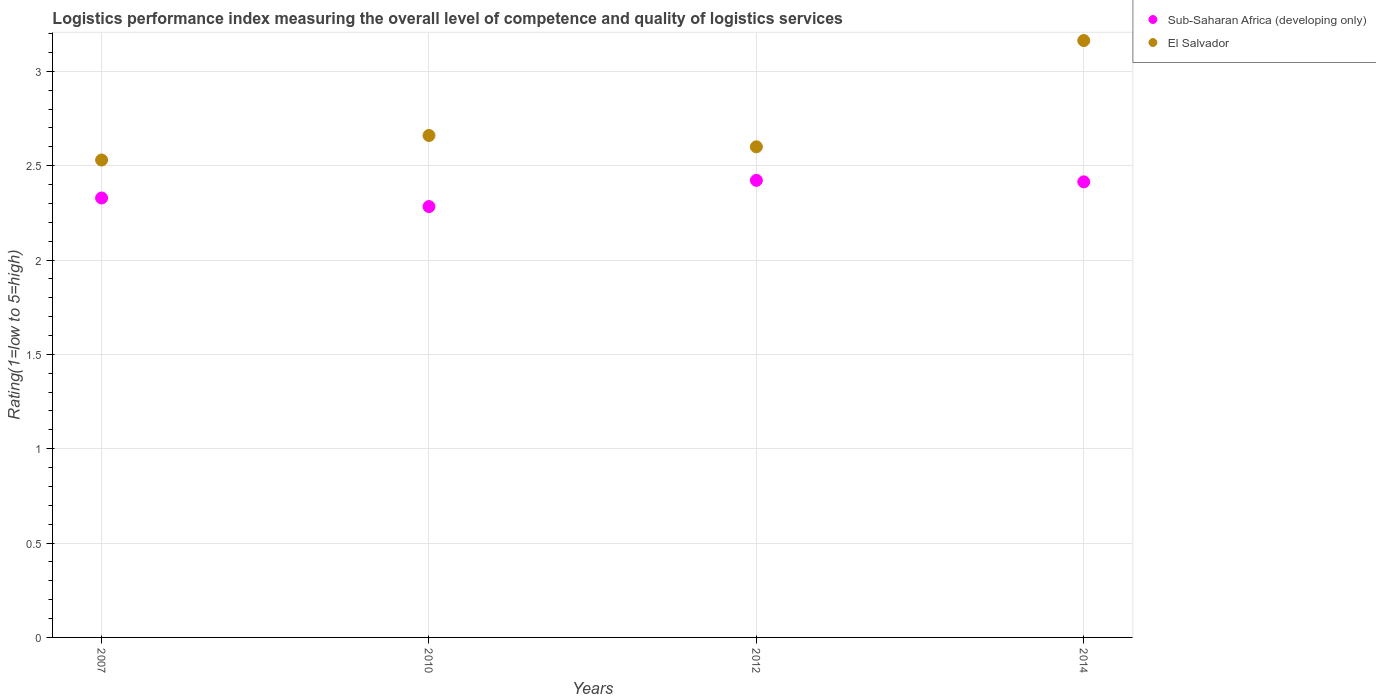How many different coloured dotlines are there?
Give a very brief answer. 2. Is the number of dotlines equal to the number of legend labels?
Your response must be concise. Yes. What is the Logistic performance index in Sub-Saharan Africa (developing only) in 2010?
Ensure brevity in your answer.  2.28. Across all years, what is the maximum Logistic performance index in Sub-Saharan Africa (developing only)?
Your answer should be compact. 2.42. Across all years, what is the minimum Logistic performance index in Sub-Saharan Africa (developing only)?
Your answer should be compact. 2.28. In which year was the Logistic performance index in El Salvador minimum?
Provide a short and direct response. 2007. What is the total Logistic performance index in El Salvador in the graph?
Give a very brief answer. 10.95. What is the difference between the Logistic performance index in Sub-Saharan Africa (developing only) in 2007 and that in 2012?
Your answer should be very brief. -0.09. What is the difference between the Logistic performance index in Sub-Saharan Africa (developing only) in 2014 and the Logistic performance index in El Salvador in 2012?
Provide a succinct answer. -0.19. What is the average Logistic performance index in Sub-Saharan Africa (developing only) per year?
Your answer should be very brief. 2.36. In the year 2014, what is the difference between the Logistic performance index in Sub-Saharan Africa (developing only) and Logistic performance index in El Salvador?
Provide a short and direct response. -0.75. In how many years, is the Logistic performance index in El Salvador greater than 2.6?
Offer a very short reply. 2. What is the ratio of the Logistic performance index in Sub-Saharan Africa (developing only) in 2012 to that in 2014?
Your answer should be very brief. 1. What is the difference between the highest and the second highest Logistic performance index in Sub-Saharan Africa (developing only)?
Provide a succinct answer. 0.01. What is the difference between the highest and the lowest Logistic performance index in Sub-Saharan Africa (developing only)?
Offer a very short reply. 0.14. In how many years, is the Logistic performance index in El Salvador greater than the average Logistic performance index in El Salvador taken over all years?
Give a very brief answer. 1. Is the sum of the Logistic performance index in El Salvador in 2010 and 2014 greater than the maximum Logistic performance index in Sub-Saharan Africa (developing only) across all years?
Your answer should be very brief. Yes. How many dotlines are there?
Your answer should be very brief. 2. What is the difference between two consecutive major ticks on the Y-axis?
Your answer should be very brief. 0.5. Are the values on the major ticks of Y-axis written in scientific E-notation?
Make the answer very short. No. Does the graph contain any zero values?
Offer a very short reply. No. What is the title of the graph?
Ensure brevity in your answer.  Logistics performance index measuring the overall level of competence and quality of logistics services. Does "Low income" appear as one of the legend labels in the graph?
Your answer should be compact. No. What is the label or title of the X-axis?
Offer a very short reply. Years. What is the label or title of the Y-axis?
Your answer should be very brief. Rating(1=low to 5=high). What is the Rating(1=low to 5=high) in Sub-Saharan Africa (developing only) in 2007?
Your response must be concise. 2.33. What is the Rating(1=low to 5=high) in El Salvador in 2007?
Your answer should be compact. 2.53. What is the Rating(1=low to 5=high) of Sub-Saharan Africa (developing only) in 2010?
Give a very brief answer. 2.28. What is the Rating(1=low to 5=high) in El Salvador in 2010?
Keep it short and to the point. 2.66. What is the Rating(1=low to 5=high) in Sub-Saharan Africa (developing only) in 2012?
Ensure brevity in your answer.  2.42. What is the Rating(1=low to 5=high) of El Salvador in 2012?
Offer a very short reply. 2.6. What is the Rating(1=low to 5=high) of Sub-Saharan Africa (developing only) in 2014?
Your answer should be very brief. 2.41. What is the Rating(1=low to 5=high) of El Salvador in 2014?
Make the answer very short. 3.16. Across all years, what is the maximum Rating(1=low to 5=high) in Sub-Saharan Africa (developing only)?
Your response must be concise. 2.42. Across all years, what is the maximum Rating(1=low to 5=high) in El Salvador?
Your response must be concise. 3.16. Across all years, what is the minimum Rating(1=low to 5=high) in Sub-Saharan Africa (developing only)?
Offer a terse response. 2.28. Across all years, what is the minimum Rating(1=low to 5=high) of El Salvador?
Provide a short and direct response. 2.53. What is the total Rating(1=low to 5=high) in Sub-Saharan Africa (developing only) in the graph?
Give a very brief answer. 9.45. What is the total Rating(1=low to 5=high) of El Salvador in the graph?
Give a very brief answer. 10.95. What is the difference between the Rating(1=low to 5=high) of Sub-Saharan Africa (developing only) in 2007 and that in 2010?
Give a very brief answer. 0.05. What is the difference between the Rating(1=low to 5=high) in El Salvador in 2007 and that in 2010?
Offer a terse response. -0.13. What is the difference between the Rating(1=low to 5=high) in Sub-Saharan Africa (developing only) in 2007 and that in 2012?
Offer a terse response. -0.09. What is the difference between the Rating(1=low to 5=high) in El Salvador in 2007 and that in 2012?
Give a very brief answer. -0.07. What is the difference between the Rating(1=low to 5=high) of Sub-Saharan Africa (developing only) in 2007 and that in 2014?
Offer a terse response. -0.09. What is the difference between the Rating(1=low to 5=high) of El Salvador in 2007 and that in 2014?
Your answer should be compact. -0.63. What is the difference between the Rating(1=low to 5=high) of Sub-Saharan Africa (developing only) in 2010 and that in 2012?
Your answer should be compact. -0.14. What is the difference between the Rating(1=low to 5=high) in El Salvador in 2010 and that in 2012?
Make the answer very short. 0.06. What is the difference between the Rating(1=low to 5=high) of Sub-Saharan Africa (developing only) in 2010 and that in 2014?
Your answer should be very brief. -0.13. What is the difference between the Rating(1=low to 5=high) of El Salvador in 2010 and that in 2014?
Your answer should be compact. -0.5. What is the difference between the Rating(1=low to 5=high) in Sub-Saharan Africa (developing only) in 2012 and that in 2014?
Keep it short and to the point. 0.01. What is the difference between the Rating(1=low to 5=high) of El Salvador in 2012 and that in 2014?
Ensure brevity in your answer.  -0.56. What is the difference between the Rating(1=low to 5=high) in Sub-Saharan Africa (developing only) in 2007 and the Rating(1=low to 5=high) in El Salvador in 2010?
Give a very brief answer. -0.33. What is the difference between the Rating(1=low to 5=high) in Sub-Saharan Africa (developing only) in 2007 and the Rating(1=low to 5=high) in El Salvador in 2012?
Make the answer very short. -0.27. What is the difference between the Rating(1=low to 5=high) in Sub-Saharan Africa (developing only) in 2007 and the Rating(1=low to 5=high) in El Salvador in 2014?
Ensure brevity in your answer.  -0.83. What is the difference between the Rating(1=low to 5=high) of Sub-Saharan Africa (developing only) in 2010 and the Rating(1=low to 5=high) of El Salvador in 2012?
Ensure brevity in your answer.  -0.32. What is the difference between the Rating(1=low to 5=high) of Sub-Saharan Africa (developing only) in 2010 and the Rating(1=low to 5=high) of El Salvador in 2014?
Ensure brevity in your answer.  -0.88. What is the difference between the Rating(1=low to 5=high) in Sub-Saharan Africa (developing only) in 2012 and the Rating(1=low to 5=high) in El Salvador in 2014?
Make the answer very short. -0.74. What is the average Rating(1=low to 5=high) in Sub-Saharan Africa (developing only) per year?
Your response must be concise. 2.36. What is the average Rating(1=low to 5=high) in El Salvador per year?
Your answer should be very brief. 2.74. In the year 2007, what is the difference between the Rating(1=low to 5=high) in Sub-Saharan Africa (developing only) and Rating(1=low to 5=high) in El Salvador?
Keep it short and to the point. -0.2. In the year 2010, what is the difference between the Rating(1=low to 5=high) in Sub-Saharan Africa (developing only) and Rating(1=low to 5=high) in El Salvador?
Offer a very short reply. -0.38. In the year 2012, what is the difference between the Rating(1=low to 5=high) in Sub-Saharan Africa (developing only) and Rating(1=low to 5=high) in El Salvador?
Offer a very short reply. -0.18. In the year 2014, what is the difference between the Rating(1=low to 5=high) of Sub-Saharan Africa (developing only) and Rating(1=low to 5=high) of El Salvador?
Your answer should be very brief. -0.75. What is the ratio of the Rating(1=low to 5=high) in Sub-Saharan Africa (developing only) in 2007 to that in 2010?
Provide a short and direct response. 1.02. What is the ratio of the Rating(1=low to 5=high) of El Salvador in 2007 to that in 2010?
Offer a very short reply. 0.95. What is the ratio of the Rating(1=low to 5=high) of Sub-Saharan Africa (developing only) in 2007 to that in 2012?
Your answer should be very brief. 0.96. What is the ratio of the Rating(1=low to 5=high) of El Salvador in 2007 to that in 2012?
Give a very brief answer. 0.97. What is the ratio of the Rating(1=low to 5=high) of Sub-Saharan Africa (developing only) in 2007 to that in 2014?
Ensure brevity in your answer.  0.96. What is the ratio of the Rating(1=low to 5=high) in El Salvador in 2007 to that in 2014?
Give a very brief answer. 0.8. What is the ratio of the Rating(1=low to 5=high) in Sub-Saharan Africa (developing only) in 2010 to that in 2012?
Your response must be concise. 0.94. What is the ratio of the Rating(1=low to 5=high) in El Salvador in 2010 to that in 2012?
Your answer should be very brief. 1.02. What is the ratio of the Rating(1=low to 5=high) in Sub-Saharan Africa (developing only) in 2010 to that in 2014?
Give a very brief answer. 0.95. What is the ratio of the Rating(1=low to 5=high) in El Salvador in 2010 to that in 2014?
Ensure brevity in your answer.  0.84. What is the ratio of the Rating(1=low to 5=high) in Sub-Saharan Africa (developing only) in 2012 to that in 2014?
Your response must be concise. 1. What is the ratio of the Rating(1=low to 5=high) of El Salvador in 2012 to that in 2014?
Your response must be concise. 0.82. What is the difference between the highest and the second highest Rating(1=low to 5=high) of Sub-Saharan Africa (developing only)?
Provide a short and direct response. 0.01. What is the difference between the highest and the second highest Rating(1=low to 5=high) of El Salvador?
Provide a succinct answer. 0.5. What is the difference between the highest and the lowest Rating(1=low to 5=high) of Sub-Saharan Africa (developing only)?
Provide a short and direct response. 0.14. What is the difference between the highest and the lowest Rating(1=low to 5=high) of El Salvador?
Keep it short and to the point. 0.63. 